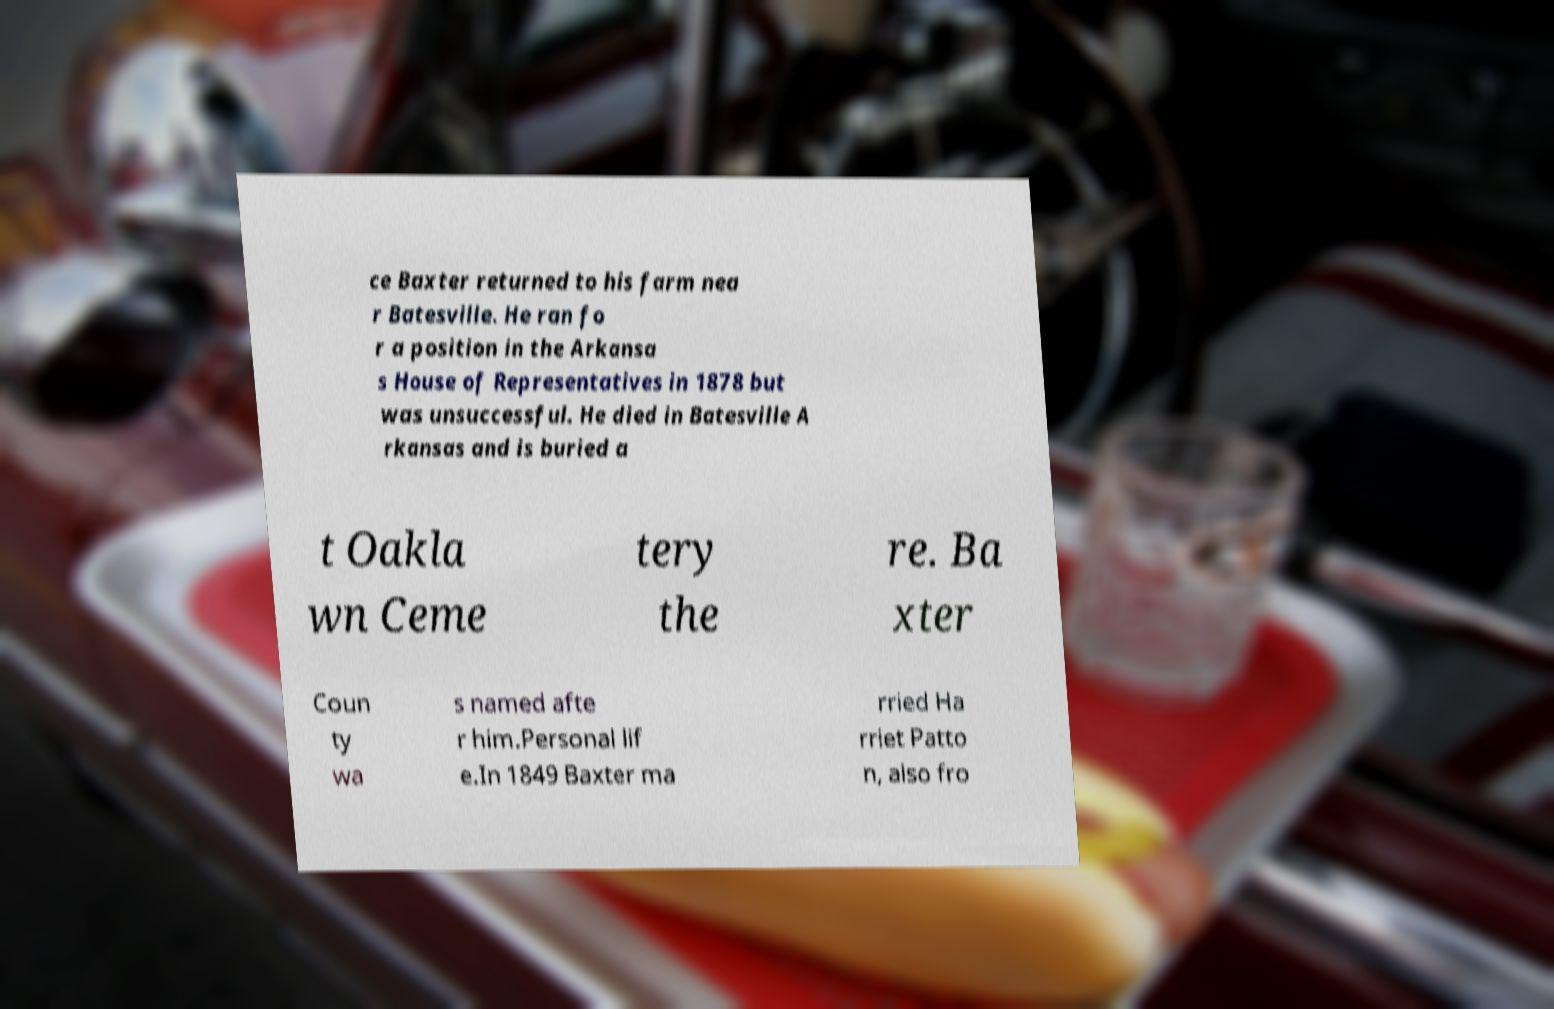Please identify and transcribe the text found in this image. ce Baxter returned to his farm nea r Batesville. He ran fo r a position in the Arkansa s House of Representatives in 1878 but was unsuccessful. He died in Batesville A rkansas and is buried a t Oakla wn Ceme tery the re. Ba xter Coun ty wa s named afte r him.Personal lif e.In 1849 Baxter ma rried Ha rriet Patto n, also fro 